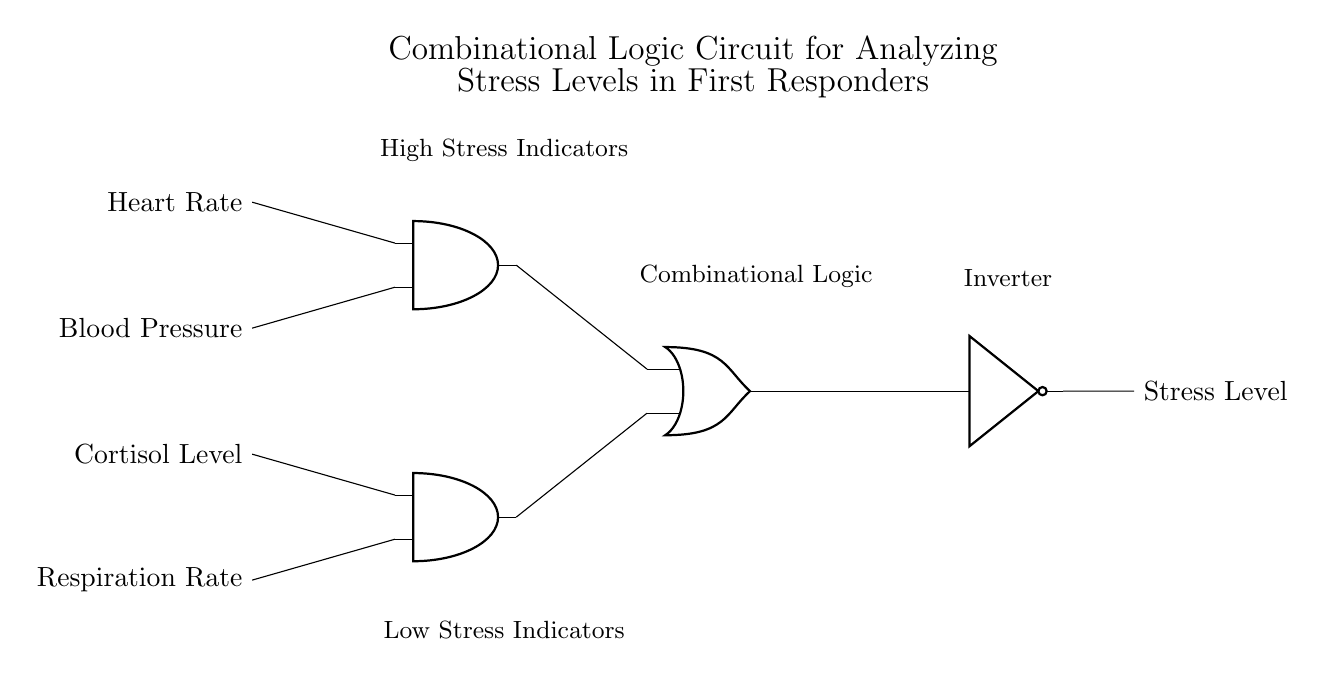What are the inputs to the circuit? The inputs to the circuit are Heart Rate, Blood Pressure, Cortisol Level, and Respiration Rate, indicated by the labels on the left side of the diagram.
Answer: Heart Rate, Blood Pressure, Cortisol Level, Respiration Rate What type of logic gate is used for combining high stress indicators? The circuit uses an AND gate for combining the inputs designated as high stress indicators, which can be seen from the positioning and label of the first AND gate.
Answer: AND gate How many AND gates are present in the circuit? There are two AND gates in the circuit, as denoted by the two distinct symbols identified on the diagram.
Answer: Two What is the function of the NOT gate in the circuit? The NOT gate functions as an inverter, which takes the output from the OR gate and inverts it, producing the opposite signal at its output.
Answer: Inversion What is the expected output if both AND gate inputs are high? If both inputs to the AND gate for high stress indicators are high, the output of that AND gate will be high, which contributes to the final output from the OR gate for stress levels.
Answer: High What is the purpose of the OR gate in this circuit? The OR gate combines the outputs from the two AND gates, leading to a stress level signal that can be high if either the high stress indicators or the low stress indicators are active.
Answer: Combination of signals What does the final output represent? The final output represents the overall stress level derived from the combined biometric inputs processed through the logic gates as shown in the diagram.
Answer: Stress Level 